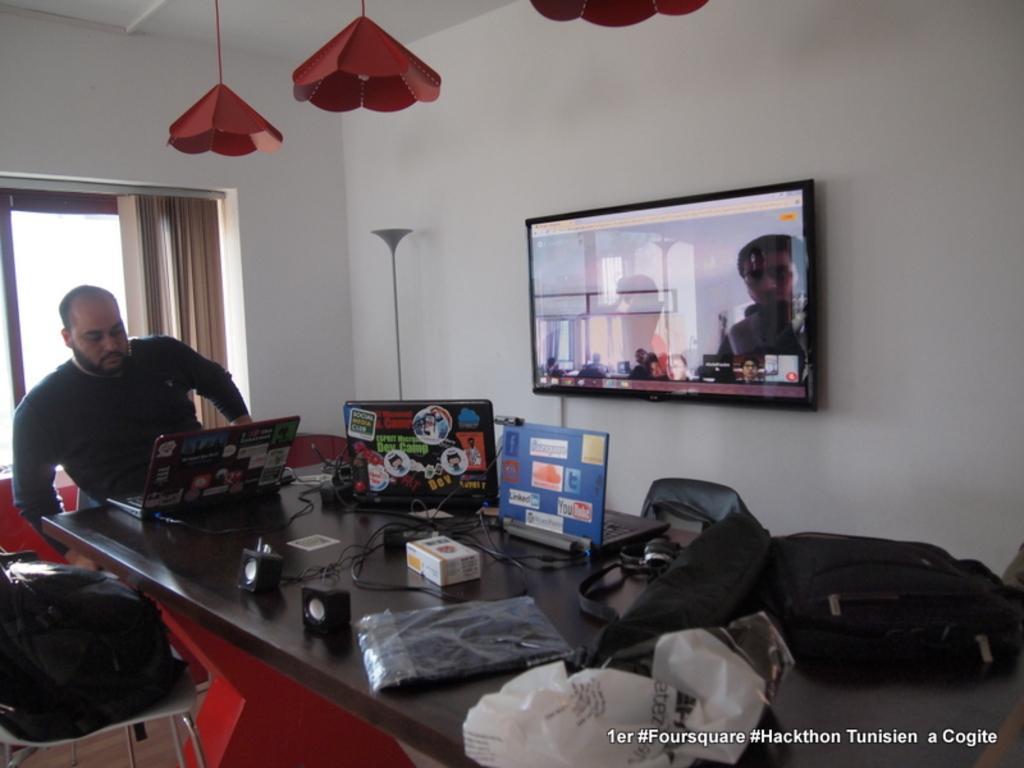How would you summarize this image in a sentence or two? As we can see in the image there is a white color wall, window, curtain, screen, a man sitting on chair and a table. On table there is a camera, covers, banners and laptops. 